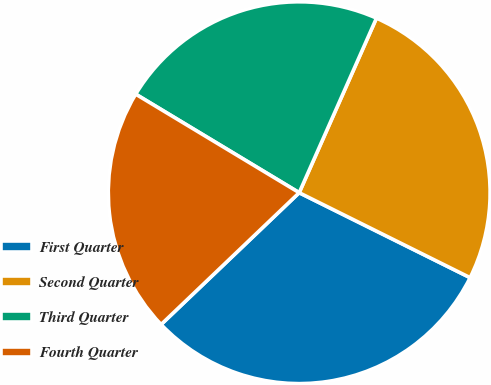Convert chart to OTSL. <chart><loc_0><loc_0><loc_500><loc_500><pie_chart><fcel>First Quarter<fcel>Second Quarter<fcel>Third Quarter<fcel>Fourth Quarter<nl><fcel>30.53%<fcel>25.71%<fcel>23.0%<fcel>20.76%<nl></chart> 